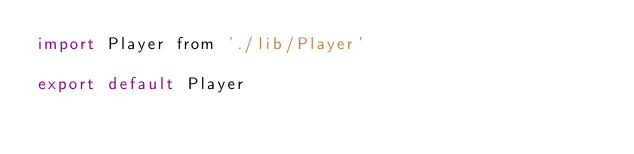Convert code to text. <code><loc_0><loc_0><loc_500><loc_500><_JavaScript_>import Player from './lib/Player'

export default Player
</code> 